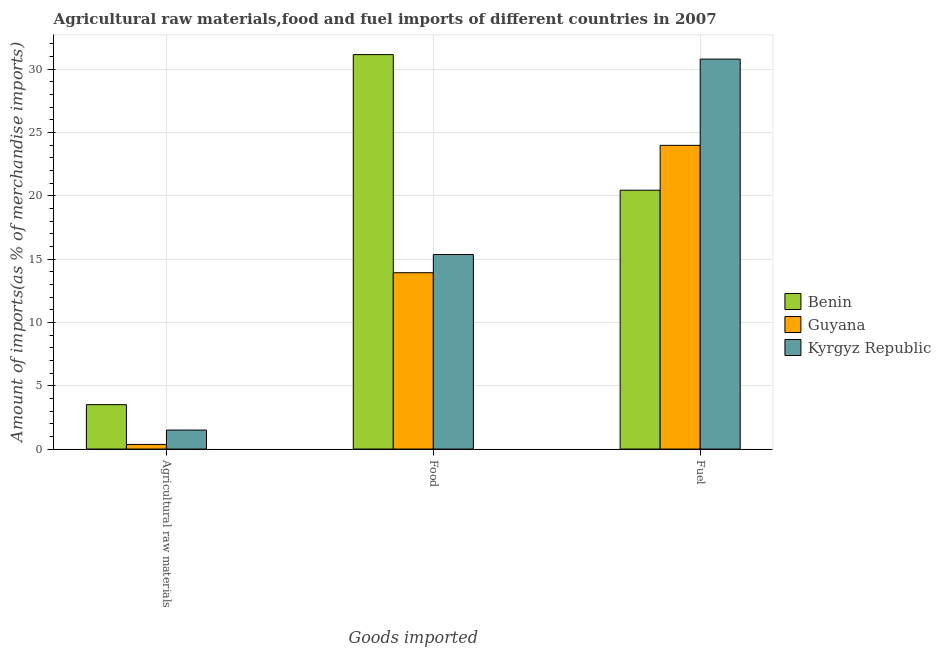How many different coloured bars are there?
Give a very brief answer. 3. Are the number of bars on each tick of the X-axis equal?
Offer a terse response. Yes. How many bars are there on the 3rd tick from the left?
Your response must be concise. 3. What is the label of the 3rd group of bars from the left?
Ensure brevity in your answer.  Fuel. What is the percentage of food imports in Guyana?
Keep it short and to the point. 13.93. Across all countries, what is the maximum percentage of fuel imports?
Offer a very short reply. 30.8. Across all countries, what is the minimum percentage of raw materials imports?
Keep it short and to the point. 0.37. In which country was the percentage of raw materials imports maximum?
Your response must be concise. Benin. In which country was the percentage of food imports minimum?
Offer a terse response. Guyana. What is the total percentage of raw materials imports in the graph?
Offer a terse response. 5.38. What is the difference between the percentage of raw materials imports in Kyrgyz Republic and that in Guyana?
Make the answer very short. 1.14. What is the difference between the percentage of fuel imports in Benin and the percentage of raw materials imports in Kyrgyz Republic?
Make the answer very short. 18.94. What is the average percentage of fuel imports per country?
Ensure brevity in your answer.  25.08. What is the difference between the percentage of raw materials imports and percentage of fuel imports in Kyrgyz Republic?
Ensure brevity in your answer.  -29.3. In how many countries, is the percentage of fuel imports greater than 10 %?
Your response must be concise. 3. What is the ratio of the percentage of food imports in Guyana to that in Benin?
Keep it short and to the point. 0.45. Is the percentage of food imports in Kyrgyz Republic less than that in Guyana?
Your response must be concise. No. What is the difference between the highest and the second highest percentage of food imports?
Your answer should be compact. 15.79. What is the difference between the highest and the lowest percentage of fuel imports?
Offer a terse response. 10.36. In how many countries, is the percentage of raw materials imports greater than the average percentage of raw materials imports taken over all countries?
Ensure brevity in your answer.  1. What does the 2nd bar from the left in Fuel represents?
Provide a succinct answer. Guyana. What does the 3rd bar from the right in Food represents?
Offer a very short reply. Benin. How many bars are there?
Your response must be concise. 9. Are all the bars in the graph horizontal?
Provide a succinct answer. No. Does the graph contain any zero values?
Your answer should be compact. No. Does the graph contain grids?
Make the answer very short. Yes. How many legend labels are there?
Your answer should be very brief. 3. How are the legend labels stacked?
Your response must be concise. Vertical. What is the title of the graph?
Your response must be concise. Agricultural raw materials,food and fuel imports of different countries in 2007. Does "Cabo Verde" appear as one of the legend labels in the graph?
Your answer should be very brief. No. What is the label or title of the X-axis?
Your response must be concise. Goods imported. What is the label or title of the Y-axis?
Your answer should be compact. Amount of imports(as % of merchandise imports). What is the Amount of imports(as % of merchandise imports) of Benin in Agricultural raw materials?
Your answer should be compact. 3.51. What is the Amount of imports(as % of merchandise imports) in Guyana in Agricultural raw materials?
Offer a terse response. 0.37. What is the Amount of imports(as % of merchandise imports) in Kyrgyz Republic in Agricultural raw materials?
Ensure brevity in your answer.  1.5. What is the Amount of imports(as % of merchandise imports) of Benin in Food?
Ensure brevity in your answer.  31.16. What is the Amount of imports(as % of merchandise imports) in Guyana in Food?
Ensure brevity in your answer.  13.93. What is the Amount of imports(as % of merchandise imports) in Kyrgyz Republic in Food?
Your answer should be very brief. 15.37. What is the Amount of imports(as % of merchandise imports) of Benin in Fuel?
Offer a terse response. 20.45. What is the Amount of imports(as % of merchandise imports) of Guyana in Fuel?
Give a very brief answer. 23.99. What is the Amount of imports(as % of merchandise imports) in Kyrgyz Republic in Fuel?
Keep it short and to the point. 30.8. Across all Goods imported, what is the maximum Amount of imports(as % of merchandise imports) of Benin?
Your response must be concise. 31.16. Across all Goods imported, what is the maximum Amount of imports(as % of merchandise imports) of Guyana?
Keep it short and to the point. 23.99. Across all Goods imported, what is the maximum Amount of imports(as % of merchandise imports) in Kyrgyz Republic?
Provide a short and direct response. 30.8. Across all Goods imported, what is the minimum Amount of imports(as % of merchandise imports) in Benin?
Provide a short and direct response. 3.51. Across all Goods imported, what is the minimum Amount of imports(as % of merchandise imports) in Guyana?
Keep it short and to the point. 0.37. Across all Goods imported, what is the minimum Amount of imports(as % of merchandise imports) of Kyrgyz Republic?
Keep it short and to the point. 1.5. What is the total Amount of imports(as % of merchandise imports) of Benin in the graph?
Provide a short and direct response. 55.11. What is the total Amount of imports(as % of merchandise imports) in Guyana in the graph?
Your response must be concise. 38.29. What is the total Amount of imports(as % of merchandise imports) in Kyrgyz Republic in the graph?
Provide a succinct answer. 47.67. What is the difference between the Amount of imports(as % of merchandise imports) in Benin in Agricultural raw materials and that in Food?
Give a very brief answer. -27.65. What is the difference between the Amount of imports(as % of merchandise imports) in Guyana in Agricultural raw materials and that in Food?
Give a very brief answer. -13.56. What is the difference between the Amount of imports(as % of merchandise imports) of Kyrgyz Republic in Agricultural raw materials and that in Food?
Offer a terse response. -13.87. What is the difference between the Amount of imports(as % of merchandise imports) in Benin in Agricultural raw materials and that in Fuel?
Your answer should be compact. -16.94. What is the difference between the Amount of imports(as % of merchandise imports) of Guyana in Agricultural raw materials and that in Fuel?
Provide a succinct answer. -23.62. What is the difference between the Amount of imports(as % of merchandise imports) of Kyrgyz Republic in Agricultural raw materials and that in Fuel?
Give a very brief answer. -29.3. What is the difference between the Amount of imports(as % of merchandise imports) in Benin in Food and that in Fuel?
Your response must be concise. 10.71. What is the difference between the Amount of imports(as % of merchandise imports) in Guyana in Food and that in Fuel?
Your answer should be very brief. -10.06. What is the difference between the Amount of imports(as % of merchandise imports) in Kyrgyz Republic in Food and that in Fuel?
Your response must be concise. -15.44. What is the difference between the Amount of imports(as % of merchandise imports) of Benin in Agricultural raw materials and the Amount of imports(as % of merchandise imports) of Guyana in Food?
Give a very brief answer. -10.42. What is the difference between the Amount of imports(as % of merchandise imports) in Benin in Agricultural raw materials and the Amount of imports(as % of merchandise imports) in Kyrgyz Republic in Food?
Make the answer very short. -11.86. What is the difference between the Amount of imports(as % of merchandise imports) in Guyana in Agricultural raw materials and the Amount of imports(as % of merchandise imports) in Kyrgyz Republic in Food?
Give a very brief answer. -15. What is the difference between the Amount of imports(as % of merchandise imports) of Benin in Agricultural raw materials and the Amount of imports(as % of merchandise imports) of Guyana in Fuel?
Your response must be concise. -20.48. What is the difference between the Amount of imports(as % of merchandise imports) of Benin in Agricultural raw materials and the Amount of imports(as % of merchandise imports) of Kyrgyz Republic in Fuel?
Make the answer very short. -27.29. What is the difference between the Amount of imports(as % of merchandise imports) in Guyana in Agricultural raw materials and the Amount of imports(as % of merchandise imports) in Kyrgyz Republic in Fuel?
Offer a terse response. -30.44. What is the difference between the Amount of imports(as % of merchandise imports) of Benin in Food and the Amount of imports(as % of merchandise imports) of Guyana in Fuel?
Your answer should be compact. 7.17. What is the difference between the Amount of imports(as % of merchandise imports) in Benin in Food and the Amount of imports(as % of merchandise imports) in Kyrgyz Republic in Fuel?
Make the answer very short. 0.36. What is the difference between the Amount of imports(as % of merchandise imports) in Guyana in Food and the Amount of imports(as % of merchandise imports) in Kyrgyz Republic in Fuel?
Your answer should be very brief. -16.87. What is the average Amount of imports(as % of merchandise imports) in Benin per Goods imported?
Make the answer very short. 18.37. What is the average Amount of imports(as % of merchandise imports) of Guyana per Goods imported?
Your response must be concise. 12.76. What is the average Amount of imports(as % of merchandise imports) of Kyrgyz Republic per Goods imported?
Provide a short and direct response. 15.89. What is the difference between the Amount of imports(as % of merchandise imports) in Benin and Amount of imports(as % of merchandise imports) in Guyana in Agricultural raw materials?
Give a very brief answer. 3.14. What is the difference between the Amount of imports(as % of merchandise imports) in Benin and Amount of imports(as % of merchandise imports) in Kyrgyz Republic in Agricultural raw materials?
Keep it short and to the point. 2.01. What is the difference between the Amount of imports(as % of merchandise imports) of Guyana and Amount of imports(as % of merchandise imports) of Kyrgyz Republic in Agricultural raw materials?
Your answer should be very brief. -1.14. What is the difference between the Amount of imports(as % of merchandise imports) of Benin and Amount of imports(as % of merchandise imports) of Guyana in Food?
Ensure brevity in your answer.  17.23. What is the difference between the Amount of imports(as % of merchandise imports) in Benin and Amount of imports(as % of merchandise imports) in Kyrgyz Republic in Food?
Ensure brevity in your answer.  15.79. What is the difference between the Amount of imports(as % of merchandise imports) of Guyana and Amount of imports(as % of merchandise imports) of Kyrgyz Republic in Food?
Your answer should be very brief. -1.44. What is the difference between the Amount of imports(as % of merchandise imports) in Benin and Amount of imports(as % of merchandise imports) in Guyana in Fuel?
Provide a short and direct response. -3.55. What is the difference between the Amount of imports(as % of merchandise imports) of Benin and Amount of imports(as % of merchandise imports) of Kyrgyz Republic in Fuel?
Keep it short and to the point. -10.36. What is the difference between the Amount of imports(as % of merchandise imports) in Guyana and Amount of imports(as % of merchandise imports) in Kyrgyz Republic in Fuel?
Keep it short and to the point. -6.81. What is the ratio of the Amount of imports(as % of merchandise imports) in Benin in Agricultural raw materials to that in Food?
Your answer should be very brief. 0.11. What is the ratio of the Amount of imports(as % of merchandise imports) in Guyana in Agricultural raw materials to that in Food?
Make the answer very short. 0.03. What is the ratio of the Amount of imports(as % of merchandise imports) of Kyrgyz Republic in Agricultural raw materials to that in Food?
Provide a short and direct response. 0.1. What is the ratio of the Amount of imports(as % of merchandise imports) of Benin in Agricultural raw materials to that in Fuel?
Offer a terse response. 0.17. What is the ratio of the Amount of imports(as % of merchandise imports) of Guyana in Agricultural raw materials to that in Fuel?
Keep it short and to the point. 0.02. What is the ratio of the Amount of imports(as % of merchandise imports) in Kyrgyz Republic in Agricultural raw materials to that in Fuel?
Offer a very short reply. 0.05. What is the ratio of the Amount of imports(as % of merchandise imports) of Benin in Food to that in Fuel?
Offer a very short reply. 1.52. What is the ratio of the Amount of imports(as % of merchandise imports) of Guyana in Food to that in Fuel?
Give a very brief answer. 0.58. What is the ratio of the Amount of imports(as % of merchandise imports) of Kyrgyz Republic in Food to that in Fuel?
Your answer should be very brief. 0.5. What is the difference between the highest and the second highest Amount of imports(as % of merchandise imports) of Benin?
Give a very brief answer. 10.71. What is the difference between the highest and the second highest Amount of imports(as % of merchandise imports) in Guyana?
Provide a succinct answer. 10.06. What is the difference between the highest and the second highest Amount of imports(as % of merchandise imports) in Kyrgyz Republic?
Ensure brevity in your answer.  15.44. What is the difference between the highest and the lowest Amount of imports(as % of merchandise imports) of Benin?
Your answer should be very brief. 27.65. What is the difference between the highest and the lowest Amount of imports(as % of merchandise imports) of Guyana?
Your answer should be compact. 23.62. What is the difference between the highest and the lowest Amount of imports(as % of merchandise imports) of Kyrgyz Republic?
Offer a terse response. 29.3. 